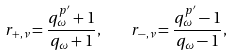<formula> <loc_0><loc_0><loc_500><loc_500>r _ { + , \nu } = \frac { q _ { \omega } ^ { p ^ { \prime } } + 1 } { q _ { \omega } + 1 } , \quad r _ { - , \nu } = \frac { q _ { \omega } ^ { p ^ { \prime } } - 1 } { q _ { \omega } - 1 } ,</formula> 